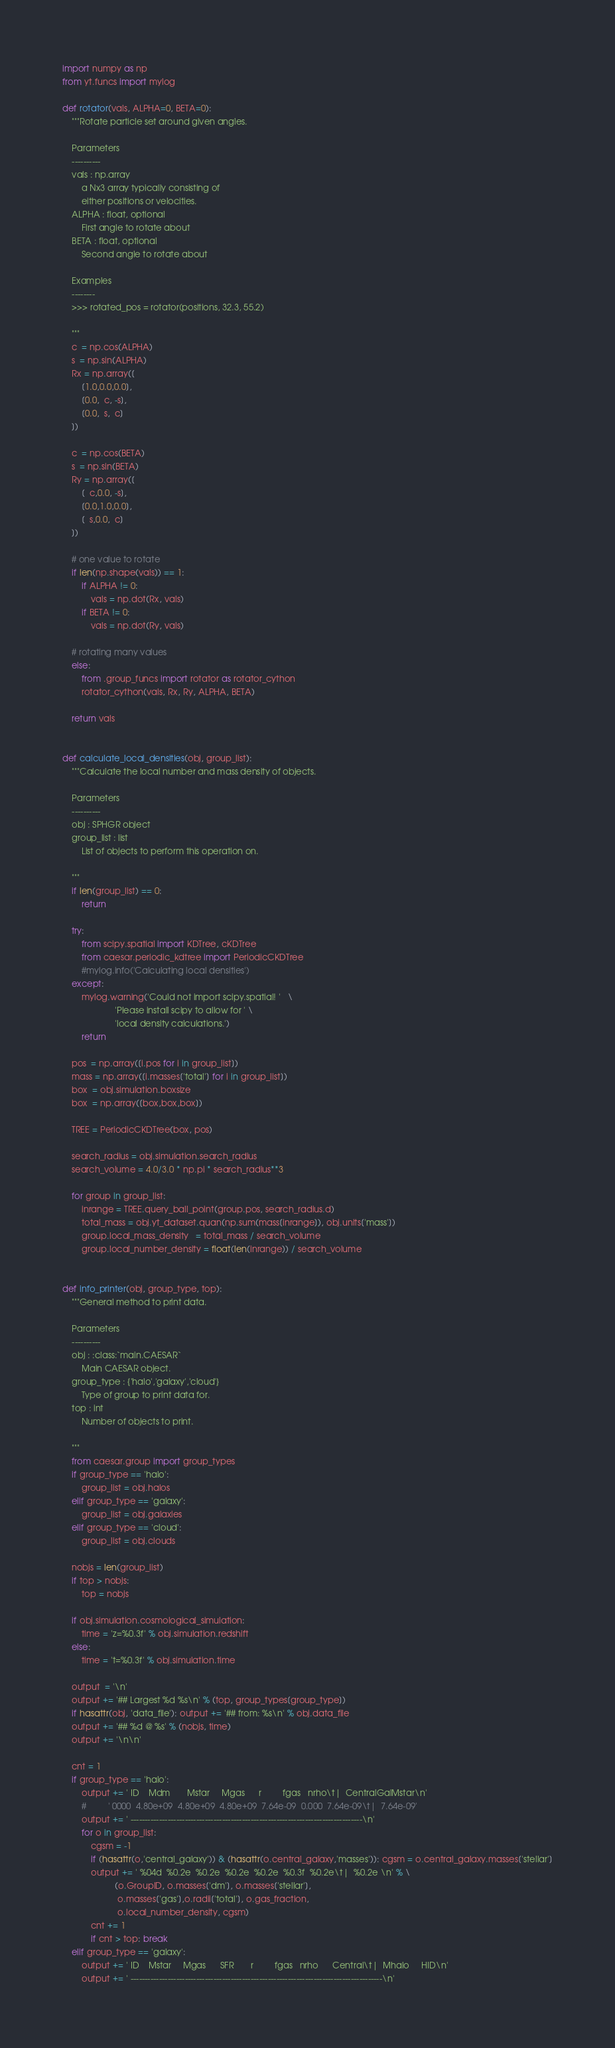<code> <loc_0><loc_0><loc_500><loc_500><_Python_>import numpy as np
from yt.funcs import mylog

def rotator(vals, ALPHA=0, BETA=0):
    """Rotate particle set around given angles.

    Parameters
    ----------
    vals : np.array
        a Nx3 array typically consisting of
        either positions or velocities.
    ALPHA : float, optional
        First angle to rotate about
    BETA : float, optional
        Second angle to rotate about

    Examples
    --------
    >>> rotated_pos = rotator(positions, 32.3, 55.2)

    """    
    c  = np.cos(ALPHA)
    s  = np.sin(ALPHA)
    Rx = np.array([
        [1.0,0.0,0.0],
        [0.0,  c, -s],
        [0.0,  s,  c]
    ])

    c  = np.cos(BETA)
    s  = np.sin(BETA)
    Ry = np.array([
        [  c,0.0, -s],
        [0.0,1.0,0.0],
        [  s,0.0,  c]
    ])
    
    # one value to rotate
    if len(np.shape(vals)) == 1:    
        if ALPHA != 0:
            vals = np.dot(Rx, vals)
        if BETA != 0:
            vals = np.dot(Ry, vals)

    # rotating many values
    else:
        from .group_funcs import rotator as rotator_cython
        rotator_cython(vals, Rx, Ry, ALPHA, BETA)
        
    return vals


def calculate_local_densities(obj, group_list):
    """Calculate the local number and mass density of objects.

    Parameters
    ----------
    obj : SPHGR object
    group_list : list
        List of objects to perform this operation on.

    """
    if len(group_list) == 0:
        return
    
    try:
        from scipy.spatial import KDTree, cKDTree
        from caesar.periodic_kdtree import PeriodicCKDTree
        #mylog.info('Calculating local densities')
    except:
        mylog.warning('Could not import scipy.spatial! '   \
                      'Please install scipy to allow for ' \
                      'local density calculations.')
        return

    pos  = np.array([i.pos for i in group_list])
    mass = np.array([i.masses['total'] for i in group_list])
    box  = obj.simulation.boxsize
    box  = np.array([box,box,box])
    
    TREE = PeriodicCKDTree(box, pos)

    search_radius = obj.simulation.search_radius
    search_volume = 4.0/3.0 * np.pi * search_radius**3

    for group in group_list:
        inrange = TREE.query_ball_point(group.pos, search_radius.d)
        total_mass = obj.yt_dataset.quan(np.sum(mass[inrange]), obj.units['mass'])
        group.local_mass_density   = total_mass / search_volume
        group.local_number_density = float(len(inrange)) / search_volume


def info_printer(obj, group_type, top):
    """General method to print data.
    
    Parameters
    ----------
    obj : :class:`main.CAESAR`
        Main CAESAR object.
    group_type : {'halo','galaxy','cloud'}
        Type of group to print data for.
    top : int
        Number of objects to print.

    """
    from caesar.group import group_types
    if group_type == 'halo':
        group_list = obj.halos
    elif group_type == 'galaxy':
        group_list = obj.galaxies
    elif group_type == 'cloud':
        group_list = obj.clouds
        
    nobjs = len(group_list)
    if top > nobjs:
        top = nobjs

    if obj.simulation.cosmological_simulation:
        time = 'z=%0.3f' % obj.simulation.redshift
    else:
        time = 't=%0.3f' % obj.simulation.time

    output  = '\n'
    output += '## Largest %d %s\n' % (top, group_types[group_type])
    if hasattr(obj, 'data_file'): output += '## from: %s\n' % obj.data_file
    output += '## %d @ %s' % (nobjs, time)
    output += '\n\n'

    cnt = 1
    if group_type == 'halo':
        output += ' ID    Mdm       Mstar     Mgas      r         fgas   nrho\t|  CentralGalMstar\n'
        #         ' 0000  4.80e+09  4.80e+09  4.80e+09  7.64e-09  0.000  7.64e-09\t|  7.64e-09'
        output += ' ---------------------------------------------------------------------------------\n'
        for o in group_list:
            cgsm = -1
            if (hasattr(o,'central_galaxy')) & (hasattr(o.central_galaxy,'masses')): cgsm = o.central_galaxy.masses['stellar']
            output += ' %04d  %0.2e  %0.2e  %0.2e  %0.2e  %0.3f  %0.2e\t|  %0.2e \n' % \
                      (o.GroupID, o.masses['dm'], o.masses['stellar'],
                       o.masses['gas'],o.radii['total'], o.gas_fraction,
                       o.local_number_density, cgsm)
            cnt += 1
            if cnt > top: break
    elif group_type == 'galaxy':
        output += ' ID    Mstar     Mgas      SFR       r         fgas   nrho      Central\t|  Mhalo     HID\n'
        output += ' ----------------------------------------------------------------------------------------\n'</code> 